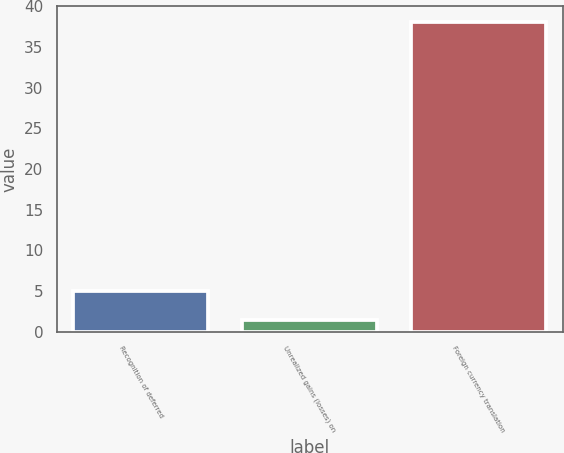<chart> <loc_0><loc_0><loc_500><loc_500><bar_chart><fcel>Recognition of deferred<fcel>Unrealized gains (losses) on<fcel>Foreign currency translation<nl><fcel>5.07<fcel>1.4<fcel>38.1<nl></chart> 